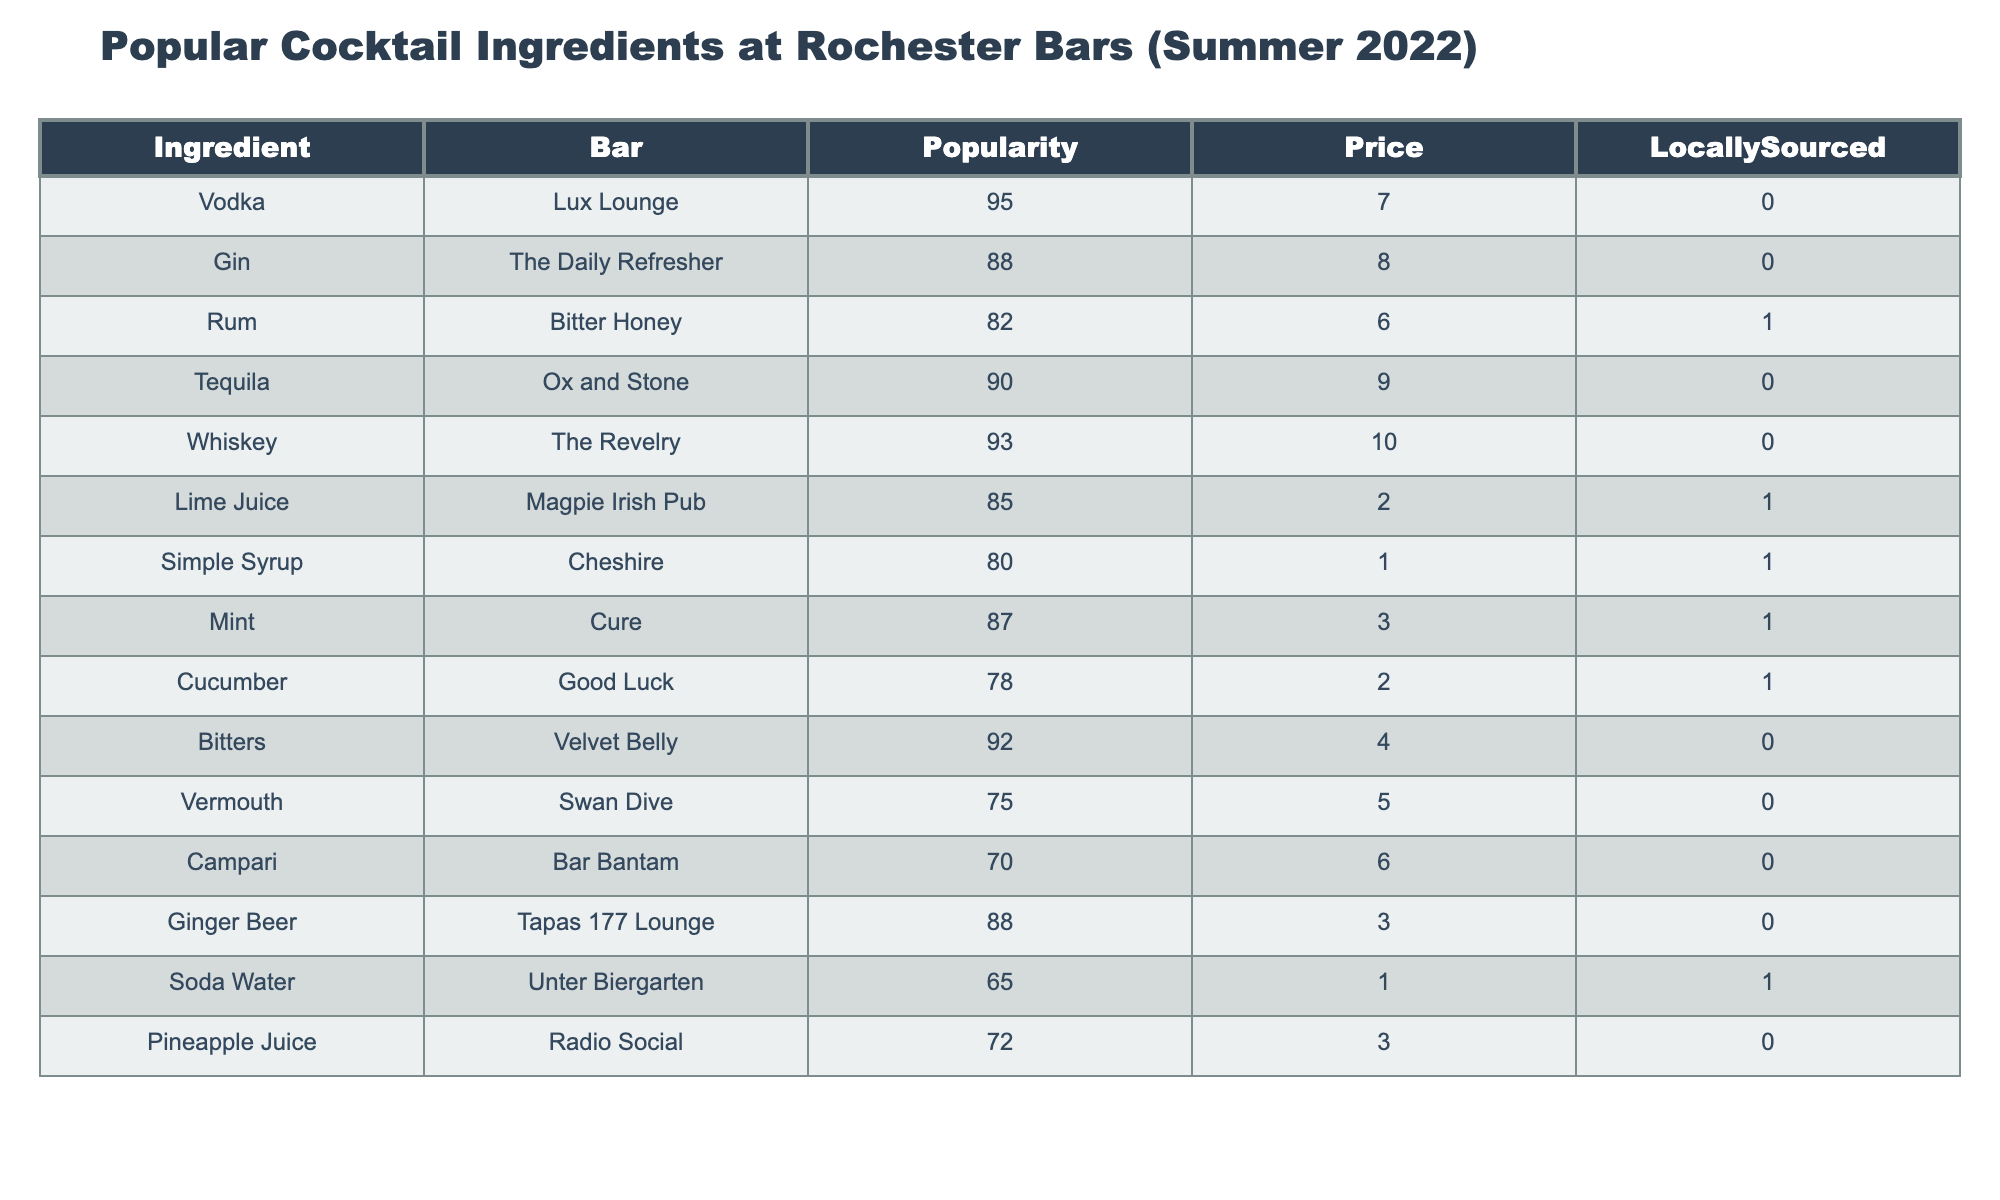What is the most popular cocktail ingredient at Rochester bars in summer 2022? To find the most popular ingredient, we look for the highest value in the Popularity column of the table. Upon checking, Vodka at Lux Lounge has the highest popularity score of 95.
Answer: Vodka How many cocktail ingredients are locally sourced? We count the ingredients under the LocallySourced column that have a value of 1. From the table, Rum, Lime Juice, Simple Syrup, Mint, Cucumber, and Soda Water are locally sourced, totaling 6 ingredients.
Answer: 6 Which bar has the ingredient with the lowest price? We look through the Price column to find the minimum value. The lowest price is 1, which is for the ingredient Simple Syrup at Cheshire.
Answer: Cheshire What is the average popularity score of all the cocktail ingredients listed? We sum the popularity scores: 95 + 88 + 82 + 90 + 93 + 85 + 80 + 87 + 78 + 92 + 75 + 70 + 88 + 65 + 72 = 1,278. There are 15 ingredients, so the average is 1,278 / 15 = 85.2.
Answer: 85.2 Is there an ingredient with a popularity score above 90 that is also locally sourced? By examining the Popularity and LocallySourced columns simultaneously, we find that the ingredients with a popularity score above 90 are Vodka, Tequila, Whiskey, and Bitters. Checking the LocallySourced column, none of these have a value of 1, meaning none are locally sourced.
Answer: No Which ingredient has the highest popularity but is not locally sourced? We scan the Popularity column for high values while ensuring that the LocallySourced column equals 0. The highest score for a non-locally sourced ingredient is Vodka with a popularity of 95.
Answer: Vodka What is the price difference between the most popular ingredient and the least popular ingredient? We find the prices: Vodka (most popular) is $7, and Campari (least popular) costs $6. The price difference is calculated as 7 - 6 = 1.
Answer: 1 How many ingredients have a price of $3 or less? We review the Price column and count the values that are 3 or below. The ingredients that meet this criterion are Lime Juice, Simple Syrup, Mint, Ginger Beer, Soda Water (5 total).
Answer: 5 Which ingredient has the highest price among those that are locally sourced? From the ingredients marked as locally sourced (Rum, Lime Juice, Simple Syrup, Mint, Cucumber, and Soda Water), we look for the highest price. Rum at Bitter Honey has the highest price of $6 among them.
Answer: Rum Are there more ingredients that are high in popularity with a price above $8? We check the Popularity column for scores above a certain threshold (let's say 85). The ingredients that meet this are Vodka, Gin, Tequila, and Whiskey. Their prices are $7, $8, $9, and $10 respectively. Thus, two out of these four ingredients are priced above $8 (Tequila and Whiskey). Yes, there are more ingredients in this category.
Answer: Yes 